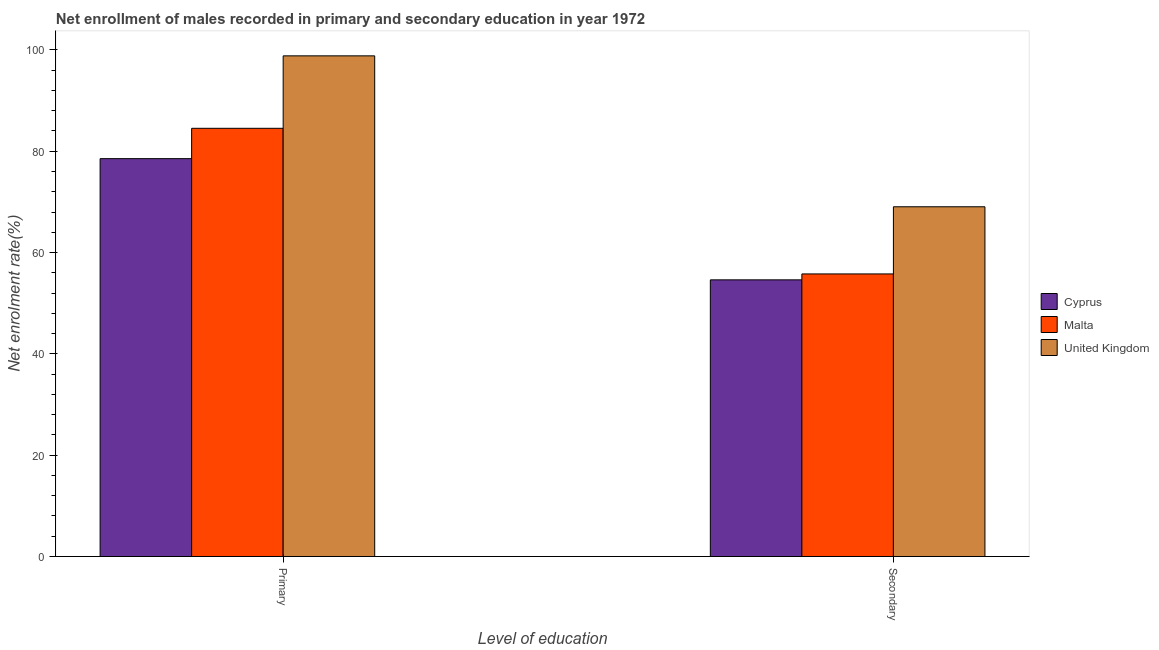How many different coloured bars are there?
Your answer should be very brief. 3. Are the number of bars on each tick of the X-axis equal?
Provide a short and direct response. Yes. How many bars are there on the 1st tick from the left?
Offer a terse response. 3. How many bars are there on the 1st tick from the right?
Provide a short and direct response. 3. What is the label of the 1st group of bars from the left?
Provide a succinct answer. Primary. What is the enrollment rate in secondary education in Cyprus?
Offer a very short reply. 54.61. Across all countries, what is the maximum enrollment rate in primary education?
Offer a terse response. 98.82. Across all countries, what is the minimum enrollment rate in secondary education?
Your answer should be compact. 54.61. In which country was the enrollment rate in secondary education maximum?
Your answer should be compact. United Kingdom. In which country was the enrollment rate in primary education minimum?
Make the answer very short. Cyprus. What is the total enrollment rate in secondary education in the graph?
Your response must be concise. 179.43. What is the difference between the enrollment rate in secondary education in United Kingdom and that in Malta?
Offer a terse response. 13.26. What is the difference between the enrollment rate in primary education in United Kingdom and the enrollment rate in secondary education in Malta?
Provide a short and direct response. 43.04. What is the average enrollment rate in primary education per country?
Provide a succinct answer. 87.29. What is the difference between the enrollment rate in secondary education and enrollment rate in primary education in Cyprus?
Keep it short and to the point. -23.93. What is the ratio of the enrollment rate in secondary education in United Kingdom to that in Malta?
Make the answer very short. 1.24. Is the enrollment rate in primary education in United Kingdom less than that in Cyprus?
Provide a short and direct response. No. In how many countries, is the enrollment rate in primary education greater than the average enrollment rate in primary education taken over all countries?
Give a very brief answer. 1. What does the 1st bar from the left in Secondary represents?
Your answer should be very brief. Cyprus. What does the 3rd bar from the right in Secondary represents?
Offer a terse response. Cyprus. How many countries are there in the graph?
Provide a succinct answer. 3. What is the difference between two consecutive major ticks on the Y-axis?
Your answer should be very brief. 20. Are the values on the major ticks of Y-axis written in scientific E-notation?
Your response must be concise. No. Does the graph contain any zero values?
Your answer should be compact. No. Does the graph contain grids?
Offer a very short reply. No. How many legend labels are there?
Your answer should be compact. 3. What is the title of the graph?
Ensure brevity in your answer.  Net enrollment of males recorded in primary and secondary education in year 1972. What is the label or title of the X-axis?
Provide a succinct answer. Level of education. What is the label or title of the Y-axis?
Your response must be concise. Net enrolment rate(%). What is the Net enrolment rate(%) of Cyprus in Primary?
Ensure brevity in your answer.  78.54. What is the Net enrolment rate(%) in Malta in Primary?
Offer a terse response. 84.52. What is the Net enrolment rate(%) in United Kingdom in Primary?
Your answer should be very brief. 98.82. What is the Net enrolment rate(%) of Cyprus in Secondary?
Offer a terse response. 54.61. What is the Net enrolment rate(%) of Malta in Secondary?
Your answer should be compact. 55.78. What is the Net enrolment rate(%) in United Kingdom in Secondary?
Offer a terse response. 69.04. Across all Level of education, what is the maximum Net enrolment rate(%) in Cyprus?
Offer a very short reply. 78.54. Across all Level of education, what is the maximum Net enrolment rate(%) of Malta?
Offer a terse response. 84.52. Across all Level of education, what is the maximum Net enrolment rate(%) in United Kingdom?
Your answer should be compact. 98.82. Across all Level of education, what is the minimum Net enrolment rate(%) in Cyprus?
Give a very brief answer. 54.61. Across all Level of education, what is the minimum Net enrolment rate(%) of Malta?
Make the answer very short. 55.78. Across all Level of education, what is the minimum Net enrolment rate(%) in United Kingdom?
Your answer should be compact. 69.04. What is the total Net enrolment rate(%) in Cyprus in the graph?
Make the answer very short. 133.14. What is the total Net enrolment rate(%) in Malta in the graph?
Provide a short and direct response. 140.3. What is the total Net enrolment rate(%) of United Kingdom in the graph?
Provide a short and direct response. 167.86. What is the difference between the Net enrolment rate(%) of Cyprus in Primary and that in Secondary?
Your answer should be very brief. 23.93. What is the difference between the Net enrolment rate(%) of Malta in Primary and that in Secondary?
Provide a succinct answer. 28.74. What is the difference between the Net enrolment rate(%) of United Kingdom in Primary and that in Secondary?
Your answer should be very brief. 29.79. What is the difference between the Net enrolment rate(%) in Cyprus in Primary and the Net enrolment rate(%) in Malta in Secondary?
Offer a very short reply. 22.75. What is the difference between the Net enrolment rate(%) in Cyprus in Primary and the Net enrolment rate(%) in United Kingdom in Secondary?
Your answer should be very brief. 9.5. What is the difference between the Net enrolment rate(%) of Malta in Primary and the Net enrolment rate(%) of United Kingdom in Secondary?
Your response must be concise. 15.49. What is the average Net enrolment rate(%) of Cyprus per Level of education?
Offer a very short reply. 66.57. What is the average Net enrolment rate(%) in Malta per Level of education?
Provide a succinct answer. 70.15. What is the average Net enrolment rate(%) in United Kingdom per Level of education?
Give a very brief answer. 83.93. What is the difference between the Net enrolment rate(%) in Cyprus and Net enrolment rate(%) in Malta in Primary?
Your response must be concise. -5.99. What is the difference between the Net enrolment rate(%) of Cyprus and Net enrolment rate(%) of United Kingdom in Primary?
Your answer should be compact. -20.29. What is the difference between the Net enrolment rate(%) in Malta and Net enrolment rate(%) in United Kingdom in Primary?
Offer a very short reply. -14.3. What is the difference between the Net enrolment rate(%) in Cyprus and Net enrolment rate(%) in Malta in Secondary?
Make the answer very short. -1.17. What is the difference between the Net enrolment rate(%) of Cyprus and Net enrolment rate(%) of United Kingdom in Secondary?
Your answer should be compact. -14.43. What is the difference between the Net enrolment rate(%) in Malta and Net enrolment rate(%) in United Kingdom in Secondary?
Your response must be concise. -13.26. What is the ratio of the Net enrolment rate(%) of Cyprus in Primary to that in Secondary?
Ensure brevity in your answer.  1.44. What is the ratio of the Net enrolment rate(%) of Malta in Primary to that in Secondary?
Offer a terse response. 1.52. What is the ratio of the Net enrolment rate(%) in United Kingdom in Primary to that in Secondary?
Provide a short and direct response. 1.43. What is the difference between the highest and the second highest Net enrolment rate(%) in Cyprus?
Your answer should be compact. 23.93. What is the difference between the highest and the second highest Net enrolment rate(%) of Malta?
Give a very brief answer. 28.74. What is the difference between the highest and the second highest Net enrolment rate(%) in United Kingdom?
Your answer should be very brief. 29.79. What is the difference between the highest and the lowest Net enrolment rate(%) of Cyprus?
Your answer should be compact. 23.93. What is the difference between the highest and the lowest Net enrolment rate(%) in Malta?
Offer a terse response. 28.74. What is the difference between the highest and the lowest Net enrolment rate(%) in United Kingdom?
Provide a short and direct response. 29.79. 